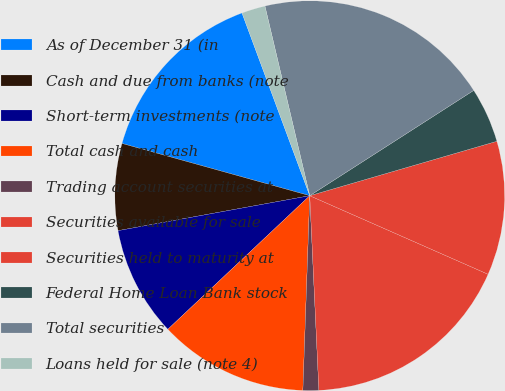<chart> <loc_0><loc_0><loc_500><loc_500><pie_chart><fcel>As of December 31 (in<fcel>Cash and due from banks (note<fcel>Short-term investments (note<fcel>Total cash and cash<fcel>Trading account securities at<fcel>Securities available for sale<fcel>Securities held to maturity at<fcel>Federal Home Loan Bank stock<fcel>Total securities<fcel>Loans held for sale (note 4)<nl><fcel>15.03%<fcel>7.19%<fcel>9.15%<fcel>12.42%<fcel>1.31%<fcel>17.65%<fcel>11.11%<fcel>4.58%<fcel>19.61%<fcel>1.96%<nl></chart> 